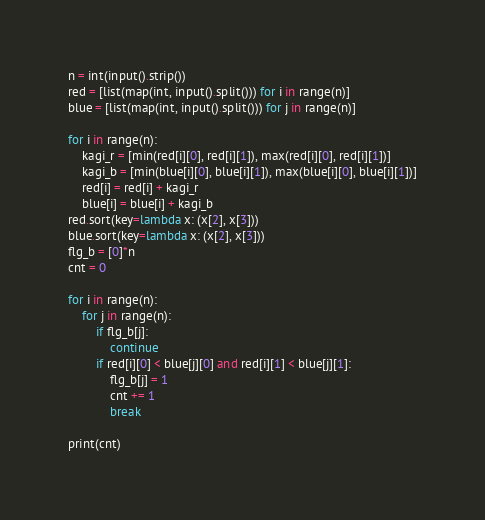<code> <loc_0><loc_0><loc_500><loc_500><_Python_>n = int(input().strip())
red = [list(map(int, input().split())) for i in range(n)]
blue = [list(map(int, input().split())) for j in range(n)]

for i in range(n):
    kagi_r = [min(red[i][0], red[i][1]), max(red[i][0], red[i][1])]
    kagi_b = [min(blue[i][0], blue[i][1]), max(blue[i][0], blue[i][1])]
    red[i] = red[i] + kagi_r
    blue[i] = blue[i] + kagi_b
red.sort(key=lambda x: (x[2], x[3]))
blue.sort(key=lambda x: (x[2], x[3]))
flg_b = [0]*n
cnt = 0

for i in range(n):
    for j in range(n):
        if flg_b[j]:
            continue
        if red[i][0] < blue[j][0] and red[i][1] < blue[j][1]:
            flg_b[j] = 1
            cnt += 1
            break

print(cnt)</code> 